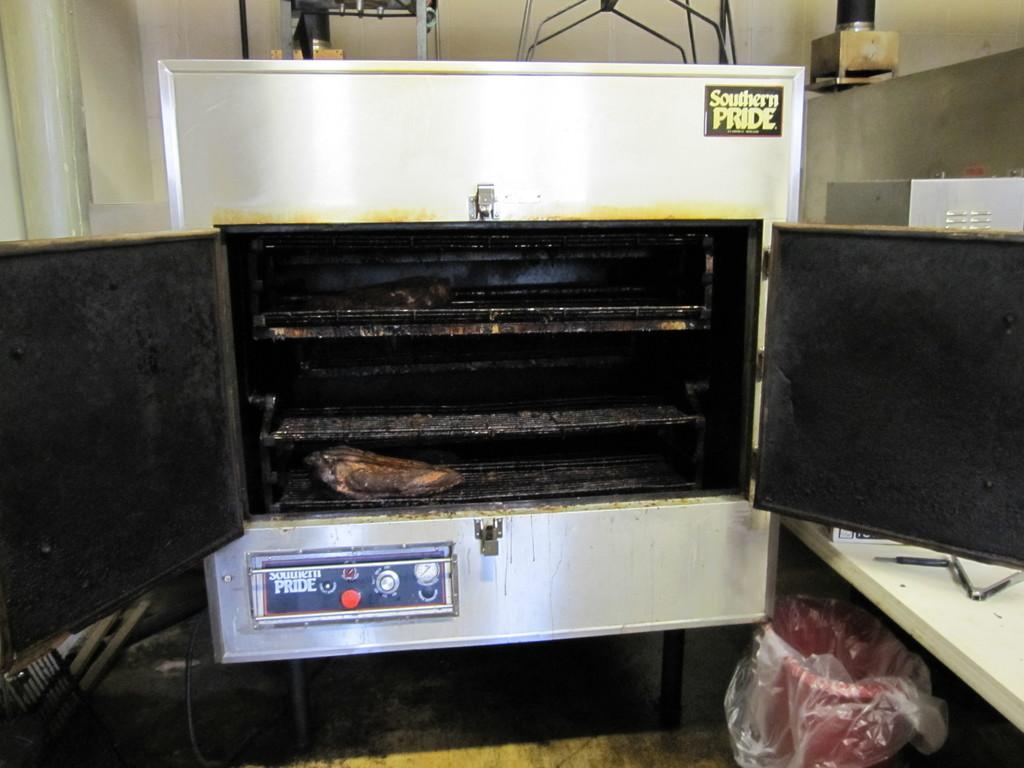<image>
Offer a succinct explanation of the picture presented. An oven that has southern pride on it 